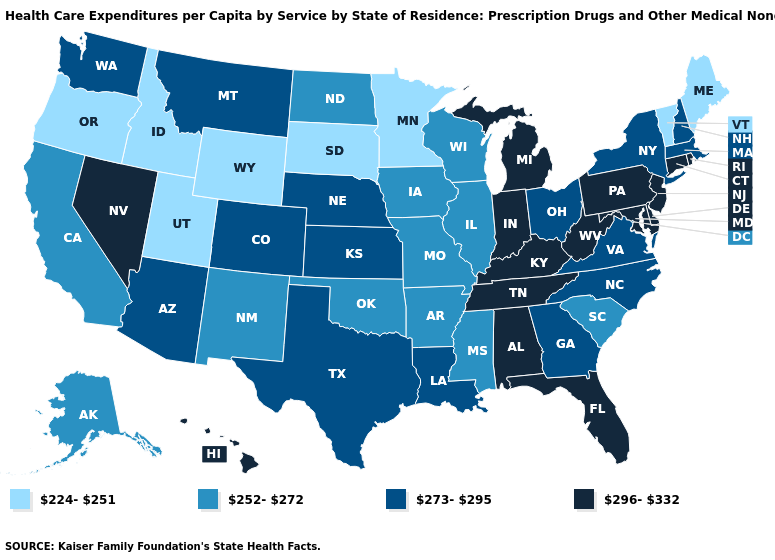Name the states that have a value in the range 273-295?
Answer briefly. Arizona, Colorado, Georgia, Kansas, Louisiana, Massachusetts, Montana, Nebraska, New Hampshire, New York, North Carolina, Ohio, Texas, Virginia, Washington. Does Arizona have a lower value than Indiana?
Answer briefly. Yes. Among the states that border West Virginia , does Ohio have the highest value?
Answer briefly. No. How many symbols are there in the legend?
Quick response, please. 4. What is the value of Arizona?
Write a very short answer. 273-295. Which states have the lowest value in the Northeast?
Concise answer only. Maine, Vermont. Among the states that border Connecticut , does Massachusetts have the highest value?
Quick response, please. No. Which states hav the highest value in the Northeast?
Answer briefly. Connecticut, New Jersey, Pennsylvania, Rhode Island. What is the value of Delaware?
Write a very short answer. 296-332. Name the states that have a value in the range 224-251?
Short answer required. Idaho, Maine, Minnesota, Oregon, South Dakota, Utah, Vermont, Wyoming. Does Michigan have the lowest value in the USA?
Short answer required. No. What is the highest value in states that border Louisiana?
Write a very short answer. 273-295. Does New York have the highest value in the Northeast?
Quick response, please. No. Does Hawaii have the highest value in the USA?
Give a very brief answer. Yes. Which states hav the highest value in the South?
Short answer required. Alabama, Delaware, Florida, Kentucky, Maryland, Tennessee, West Virginia. 